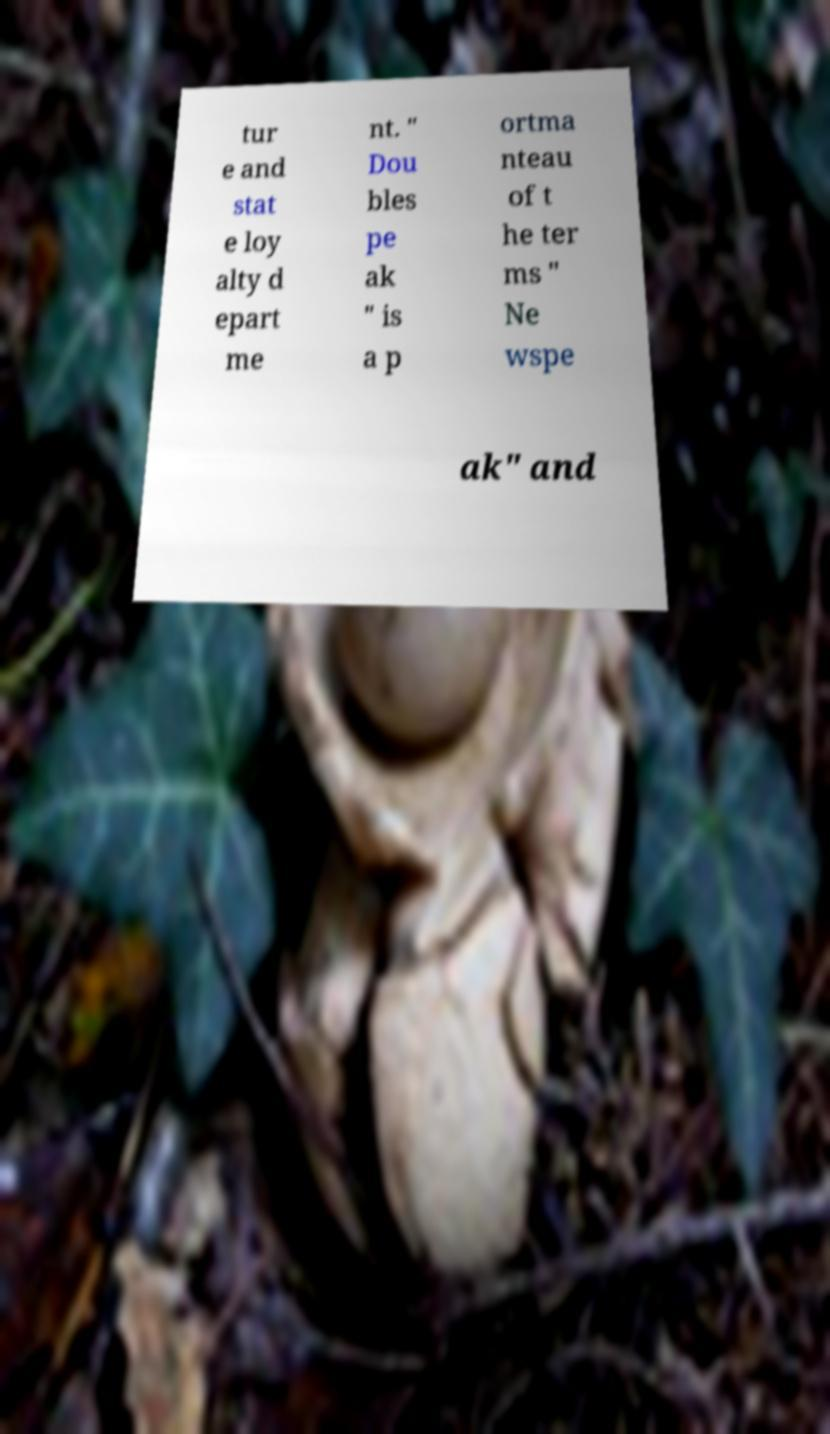I need the written content from this picture converted into text. Can you do that? tur e and stat e loy alty d epart me nt. " Dou bles pe ak " is a p ortma nteau of t he ter ms " Ne wspe ak" and 